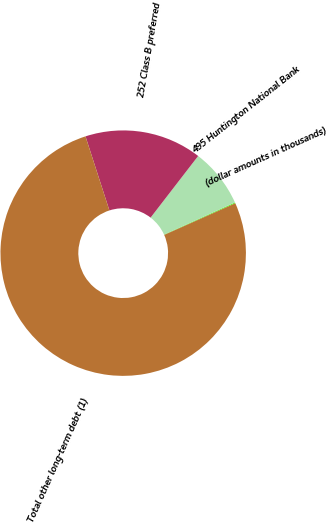Convert chart to OTSL. <chart><loc_0><loc_0><loc_500><loc_500><pie_chart><fcel>(dollar amounts in thousands)<fcel>495 Huntington National Bank<fcel>252 Class B preferred<fcel>Total other long-term debt (1)<nl><fcel>0.11%<fcel>7.77%<fcel>15.43%<fcel>76.69%<nl></chart> 